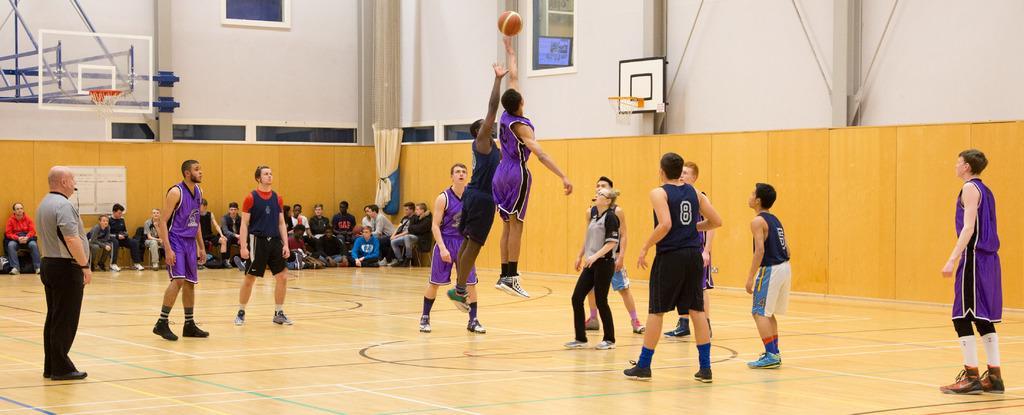Could you give a brief overview of what you see in this image? In this image we can see few people playing basket ball, two of the are blowing whistle and there are basketball nets to the boards, in the background there are few people sitting on chairs and few people sitting on the floor and there are windows, a board to the wall. 